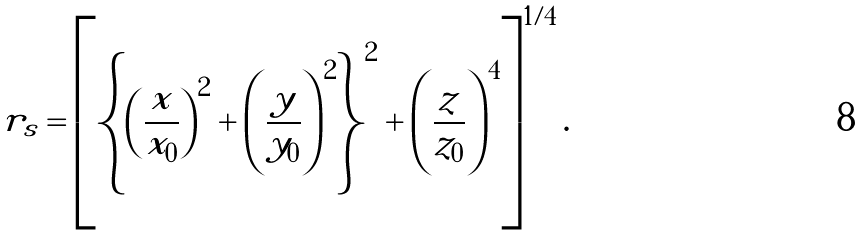Convert formula to latex. <formula><loc_0><loc_0><loc_500><loc_500>r _ { s } = \left [ \left \{ \left ( \frac { x } { x _ { 0 } } \right ) ^ { 2 } + \left ( \frac { y } { y _ { 0 } } \right ) ^ { 2 } \right \} ^ { 2 } + \left ( \frac { z } { z _ { 0 } } \right ) ^ { 4 } \right ] ^ { 1 / 4 } .</formula> 